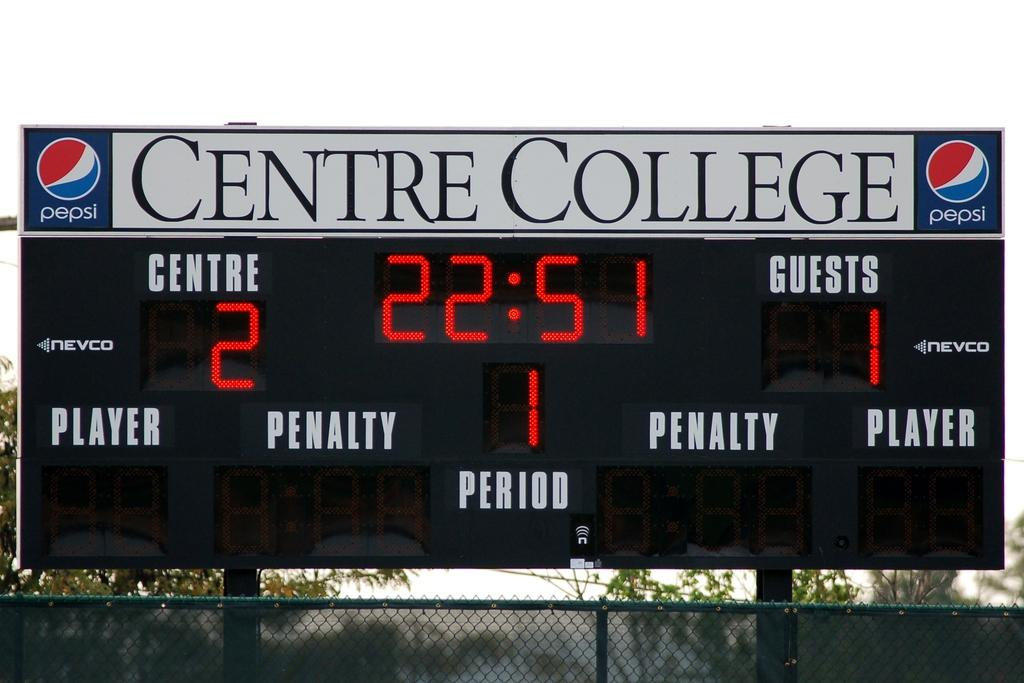What is the main object in the image? There is a display board in the image. What is written or displayed at the top of the board? The display board has a name on its top. What can be seen in the foreground of the image? There is a fence in the image. What type of natural scenery is visible in the background? There are trees and the sky visible in the background of the image. How many chairs are placed around the display board in the image? There are no chairs visible in the image; the focus is on the display board and the fence in the foreground. Can you see a squirrel climbing the trees in the background of the image? There is no squirrel present in the image; only trees and the sky are visible in the background. 